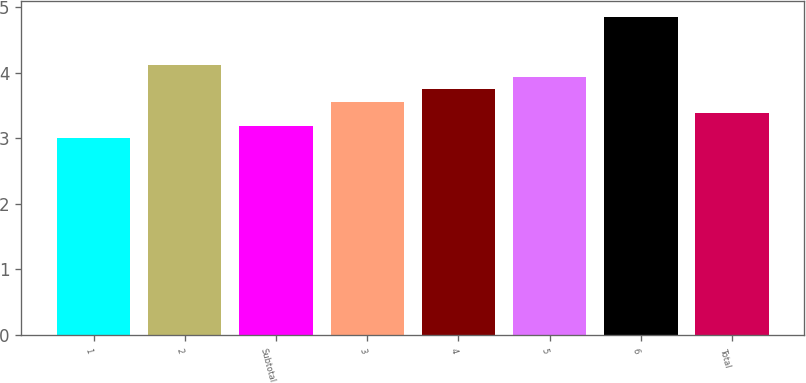Convert chart. <chart><loc_0><loc_0><loc_500><loc_500><bar_chart><fcel>1<fcel>2<fcel>Subtotal<fcel>3<fcel>4<fcel>5<fcel>6<fcel>Total<nl><fcel>3<fcel>4.12<fcel>3.19<fcel>3.56<fcel>3.75<fcel>3.94<fcel>4.85<fcel>3.38<nl></chart> 